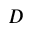Convert formula to latex. <formula><loc_0><loc_0><loc_500><loc_500>D</formula> 